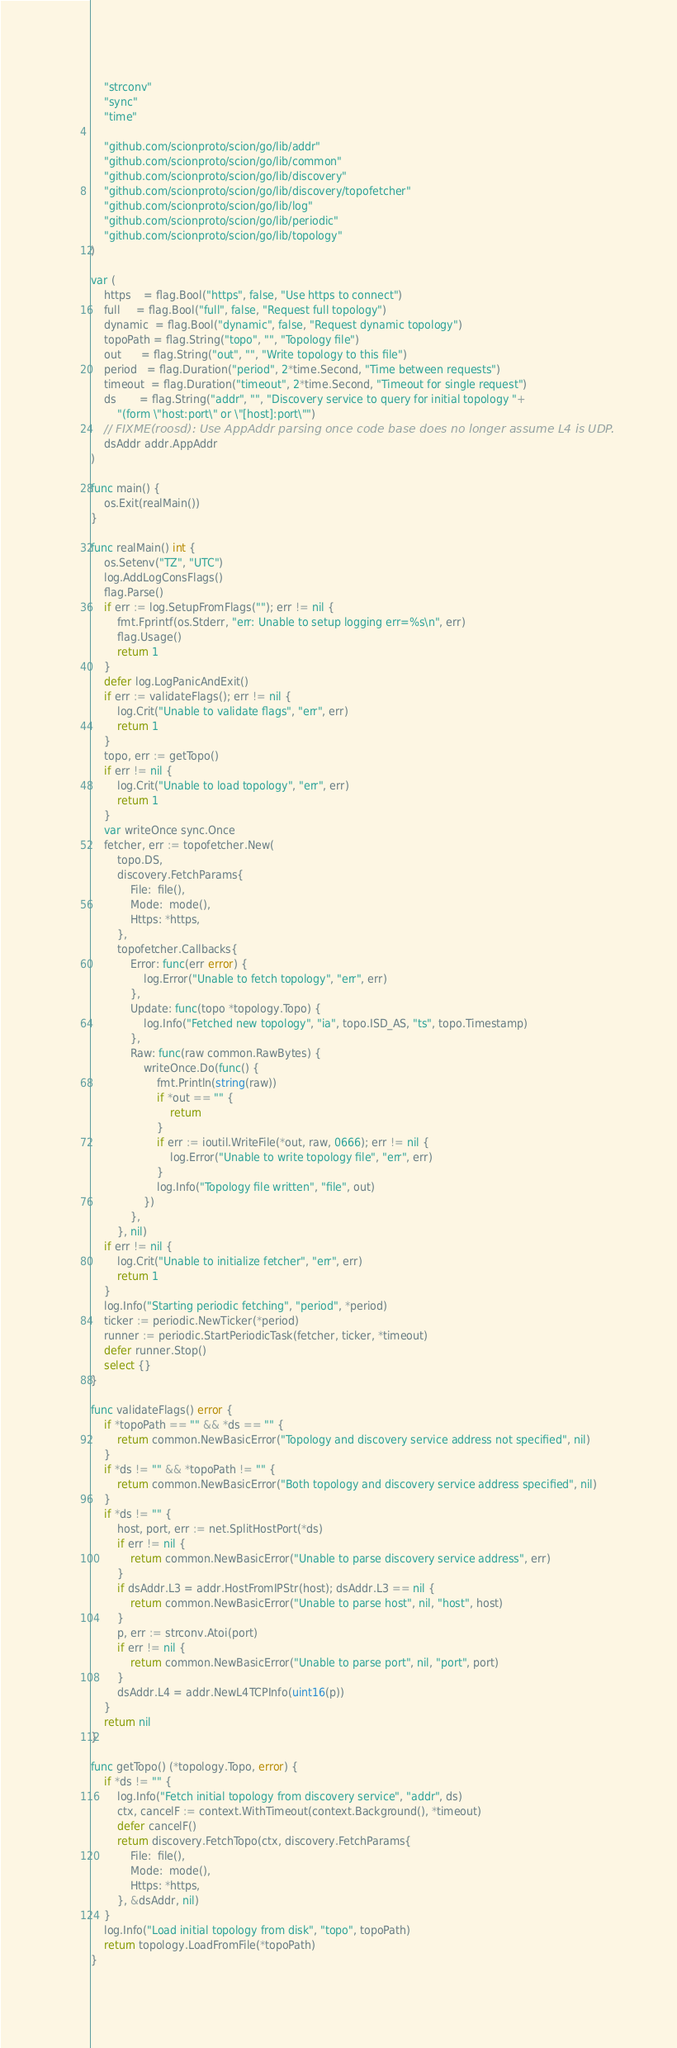Convert code to text. <code><loc_0><loc_0><loc_500><loc_500><_Go_>	"strconv"
	"sync"
	"time"

	"github.com/scionproto/scion/go/lib/addr"
	"github.com/scionproto/scion/go/lib/common"
	"github.com/scionproto/scion/go/lib/discovery"
	"github.com/scionproto/scion/go/lib/discovery/topofetcher"
	"github.com/scionproto/scion/go/lib/log"
	"github.com/scionproto/scion/go/lib/periodic"
	"github.com/scionproto/scion/go/lib/topology"
)

var (
	https    = flag.Bool("https", false, "Use https to connect")
	full     = flag.Bool("full", false, "Request full topology")
	dynamic  = flag.Bool("dynamic", false, "Request dynamic topology")
	topoPath = flag.String("topo", "", "Topology file")
	out      = flag.String("out", "", "Write topology to this file")
	period   = flag.Duration("period", 2*time.Second, "Time between requests")
	timeout  = flag.Duration("timeout", 2*time.Second, "Timeout for single request")
	ds       = flag.String("addr", "", "Discovery service to query for initial topology "+
		"(form \"host:port\" or \"[host]:port\"")
	// FIXME(roosd): Use AppAddr parsing once code base does no longer assume L4 is UDP.
	dsAddr addr.AppAddr
)

func main() {
	os.Exit(realMain())
}

func realMain() int {
	os.Setenv("TZ", "UTC")
	log.AddLogConsFlags()
	flag.Parse()
	if err := log.SetupFromFlags(""); err != nil {
		fmt.Fprintf(os.Stderr, "err: Unable to setup logging err=%s\n", err)
		flag.Usage()
		return 1
	}
	defer log.LogPanicAndExit()
	if err := validateFlags(); err != nil {
		log.Crit("Unable to validate flags", "err", err)
		return 1
	}
	topo, err := getTopo()
	if err != nil {
		log.Crit("Unable to load topology", "err", err)
		return 1
	}
	var writeOnce sync.Once
	fetcher, err := topofetcher.New(
		topo.DS,
		discovery.FetchParams{
			File:  file(),
			Mode:  mode(),
			Https: *https,
		},
		topofetcher.Callbacks{
			Error: func(err error) {
				log.Error("Unable to fetch topology", "err", err)
			},
			Update: func(topo *topology.Topo) {
				log.Info("Fetched new topology", "ia", topo.ISD_AS, "ts", topo.Timestamp)
			},
			Raw: func(raw common.RawBytes) {
				writeOnce.Do(func() {
					fmt.Println(string(raw))
					if *out == "" {
						return
					}
					if err := ioutil.WriteFile(*out, raw, 0666); err != nil {
						log.Error("Unable to write topology file", "err", err)
					}
					log.Info("Topology file written", "file", out)
				})
			},
		}, nil)
	if err != nil {
		log.Crit("Unable to initialize fetcher", "err", err)
		return 1
	}
	log.Info("Starting periodic fetching", "period", *period)
	ticker := periodic.NewTicker(*period)
	runner := periodic.StartPeriodicTask(fetcher, ticker, *timeout)
	defer runner.Stop()
	select {}
}

func validateFlags() error {
	if *topoPath == "" && *ds == "" {
		return common.NewBasicError("Topology and discovery service address not specified", nil)
	}
	if *ds != "" && *topoPath != "" {
		return common.NewBasicError("Both topology and discovery service address specified", nil)
	}
	if *ds != "" {
		host, port, err := net.SplitHostPort(*ds)
		if err != nil {
			return common.NewBasicError("Unable to parse discovery service address", err)
		}
		if dsAddr.L3 = addr.HostFromIPStr(host); dsAddr.L3 == nil {
			return common.NewBasicError("Unable to parse host", nil, "host", host)
		}
		p, err := strconv.Atoi(port)
		if err != nil {
			return common.NewBasicError("Unable to parse port", nil, "port", port)
		}
		dsAddr.L4 = addr.NewL4TCPInfo(uint16(p))
	}
	return nil
}

func getTopo() (*topology.Topo, error) {
	if *ds != "" {
		log.Info("Fetch initial topology from discovery service", "addr", ds)
		ctx, cancelF := context.WithTimeout(context.Background(), *timeout)
		defer cancelF()
		return discovery.FetchTopo(ctx, discovery.FetchParams{
			File:  file(),
			Mode:  mode(),
			Https: *https,
		}, &dsAddr, nil)
	}
	log.Info("Load initial topology from disk", "topo", topoPath)
	return topology.LoadFromFile(*topoPath)
}
</code> 